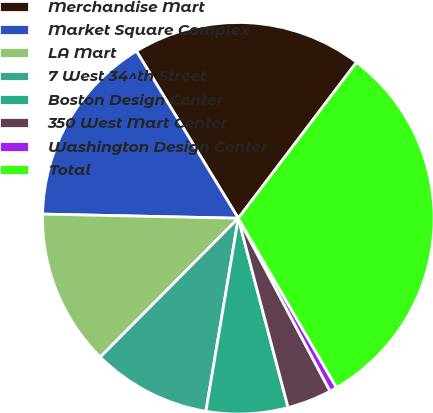<chart> <loc_0><loc_0><loc_500><loc_500><pie_chart><fcel>Merchandise Mart<fcel>Market Square Complex<fcel>LA Mart<fcel>7 West 34^th Street<fcel>Boston Design Center<fcel>350 West Mart Center<fcel>Washington Design Center<fcel>Total<nl><fcel>19.03%<fcel>15.95%<fcel>12.88%<fcel>9.81%<fcel>6.74%<fcel>3.67%<fcel>0.6%<fcel>31.31%<nl></chart> 